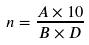Convert formula to latex. <formula><loc_0><loc_0><loc_500><loc_500>n = \frac { A \times 1 0 } { B \times D }</formula> 